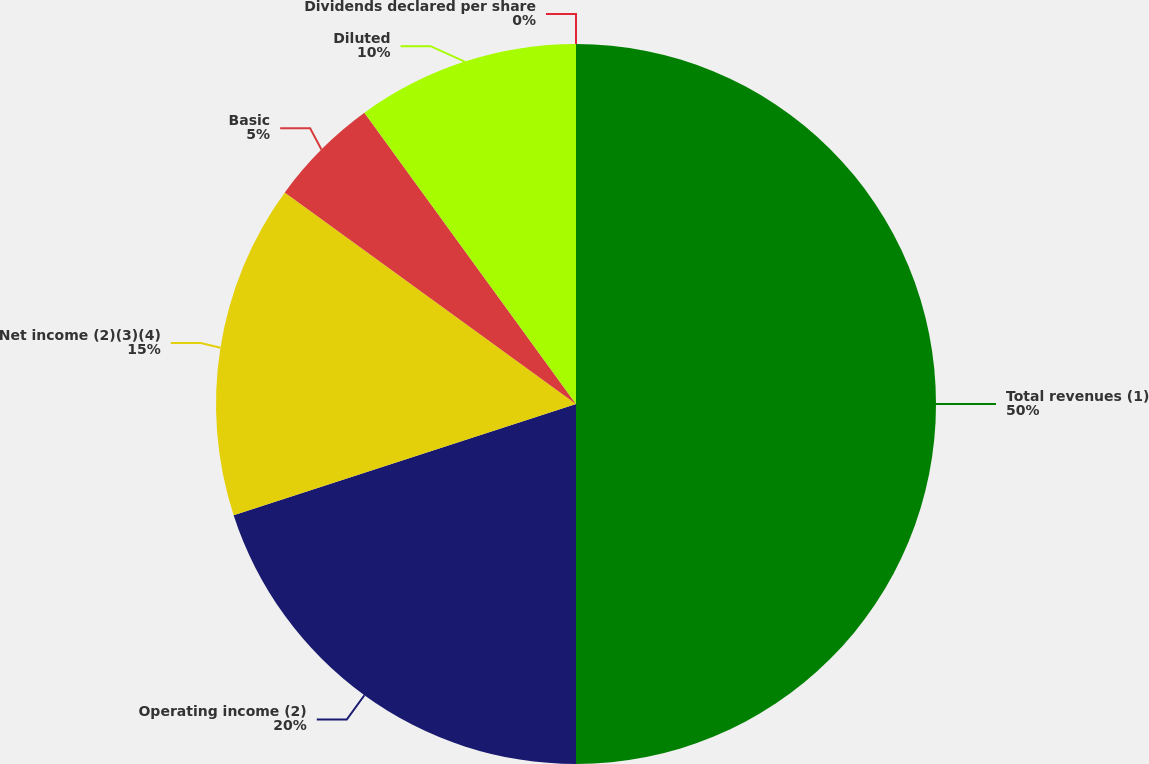Convert chart to OTSL. <chart><loc_0><loc_0><loc_500><loc_500><pie_chart><fcel>Total revenues (1)<fcel>Operating income (2)<fcel>Net income (2)(3)(4)<fcel>Basic<fcel>Diluted<fcel>Dividends declared per share<nl><fcel>50.0%<fcel>20.0%<fcel>15.0%<fcel>5.0%<fcel>10.0%<fcel>0.0%<nl></chart> 